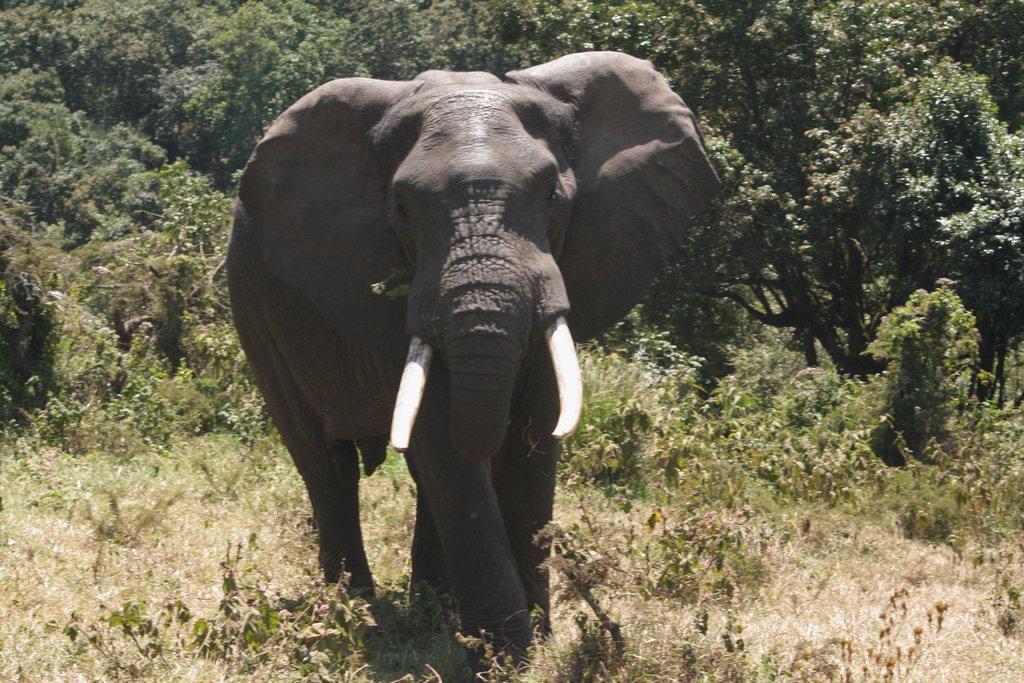Could you give a brief overview of what you see in this image? This is an elephant, these are trees. 